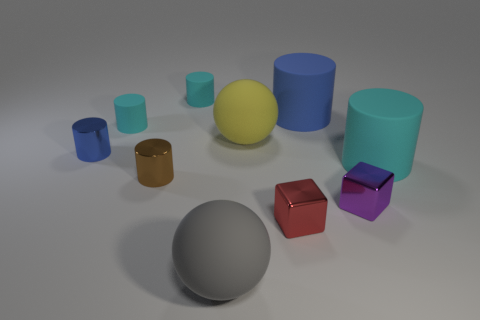Subtract all red balls. How many cyan cylinders are left? 3 Subtract 1 cylinders. How many cylinders are left? 5 Subtract all blue cylinders. How many cylinders are left? 4 Subtract all large matte cylinders. How many cylinders are left? 4 Subtract all red balls. Subtract all red cubes. How many balls are left? 2 Subtract all cylinders. How many objects are left? 4 Add 7 small cyan things. How many small cyan things exist? 9 Subtract 0 cyan balls. How many objects are left? 10 Subtract all yellow objects. Subtract all big balls. How many objects are left? 7 Add 6 yellow rubber things. How many yellow rubber things are left? 7 